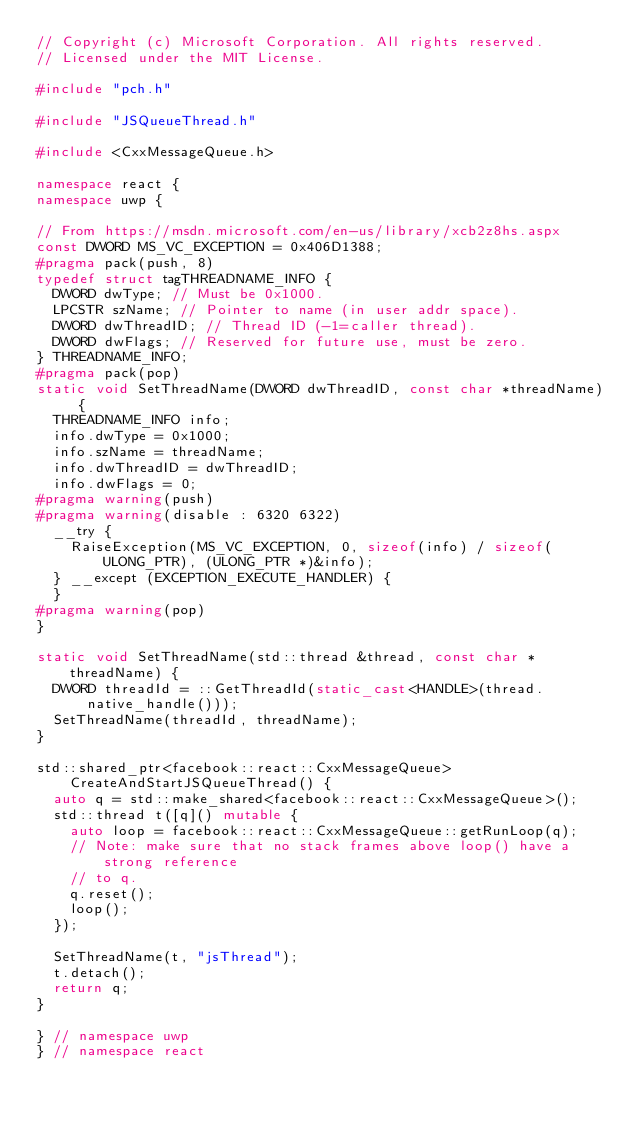Convert code to text. <code><loc_0><loc_0><loc_500><loc_500><_C++_>// Copyright (c) Microsoft Corporation. All rights reserved.
// Licensed under the MIT License.

#include "pch.h"

#include "JSQueueThread.h"

#include <CxxMessageQueue.h>

namespace react {
namespace uwp {

// From https://msdn.microsoft.com/en-us/library/xcb2z8hs.aspx
const DWORD MS_VC_EXCEPTION = 0x406D1388;
#pragma pack(push, 8)
typedef struct tagTHREADNAME_INFO {
  DWORD dwType; // Must be 0x1000.
  LPCSTR szName; // Pointer to name (in user addr space).
  DWORD dwThreadID; // Thread ID (-1=caller thread).
  DWORD dwFlags; // Reserved for future use, must be zero.
} THREADNAME_INFO;
#pragma pack(pop)
static void SetThreadName(DWORD dwThreadID, const char *threadName) {
  THREADNAME_INFO info;
  info.dwType = 0x1000;
  info.szName = threadName;
  info.dwThreadID = dwThreadID;
  info.dwFlags = 0;
#pragma warning(push)
#pragma warning(disable : 6320 6322)
  __try {
    RaiseException(MS_VC_EXCEPTION, 0, sizeof(info) / sizeof(ULONG_PTR), (ULONG_PTR *)&info);
  } __except (EXCEPTION_EXECUTE_HANDLER) {
  }
#pragma warning(pop)
}

static void SetThreadName(std::thread &thread, const char *threadName) {
  DWORD threadId = ::GetThreadId(static_cast<HANDLE>(thread.native_handle()));
  SetThreadName(threadId, threadName);
}

std::shared_ptr<facebook::react::CxxMessageQueue> CreateAndStartJSQueueThread() {
  auto q = std::make_shared<facebook::react::CxxMessageQueue>();
  std::thread t([q]() mutable {
    auto loop = facebook::react::CxxMessageQueue::getRunLoop(q);
    // Note: make sure that no stack frames above loop() have a strong reference
    // to q.
    q.reset();
    loop();
  });

  SetThreadName(t, "jsThread");
  t.detach();
  return q;
}

} // namespace uwp
} // namespace react
</code> 